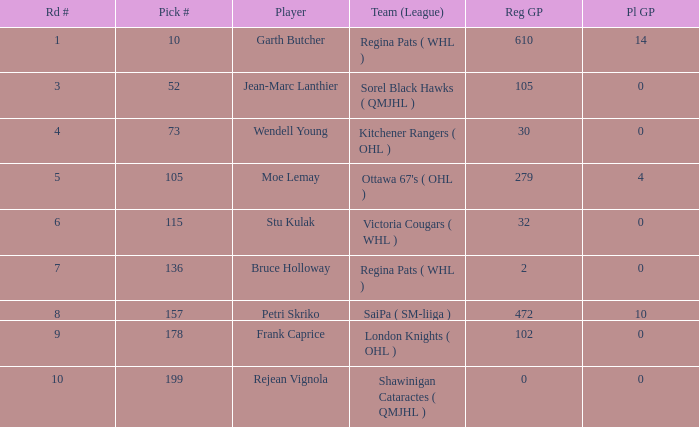What is the mean road figure when moe lemay is the competitor? 5.0. 